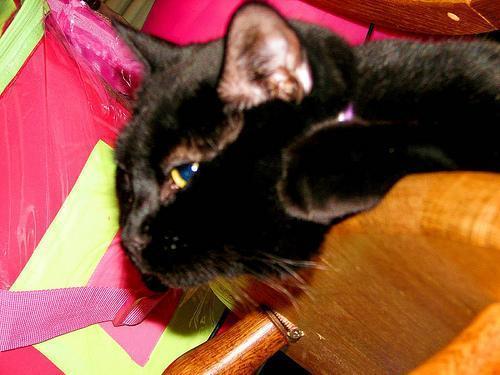How many cats are in the picture?
Give a very brief answer. 1. 